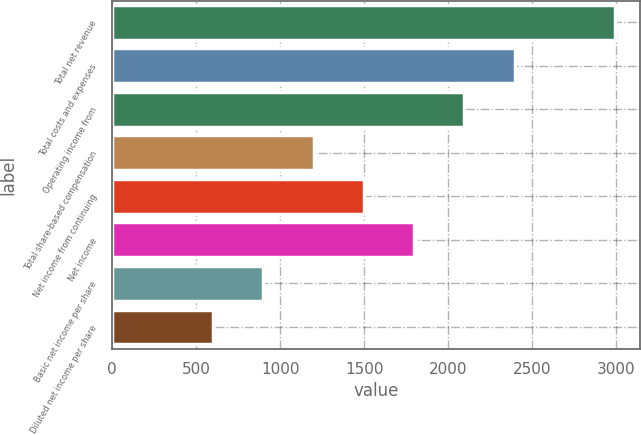Convert chart to OTSL. <chart><loc_0><loc_0><loc_500><loc_500><bar_chart><fcel>Total net revenue<fcel>Total costs and expenses<fcel>Operating income from<fcel>Total share-based compensation<fcel>Net income from continuing<fcel>Net income<fcel>Basic net income per share<fcel>Diluted net income per share<nl><fcel>2993<fcel>2394.68<fcel>2095.51<fcel>1198<fcel>1497.17<fcel>1796.34<fcel>898.83<fcel>599.66<nl></chart> 